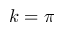<formula> <loc_0><loc_0><loc_500><loc_500>k = \pi</formula> 